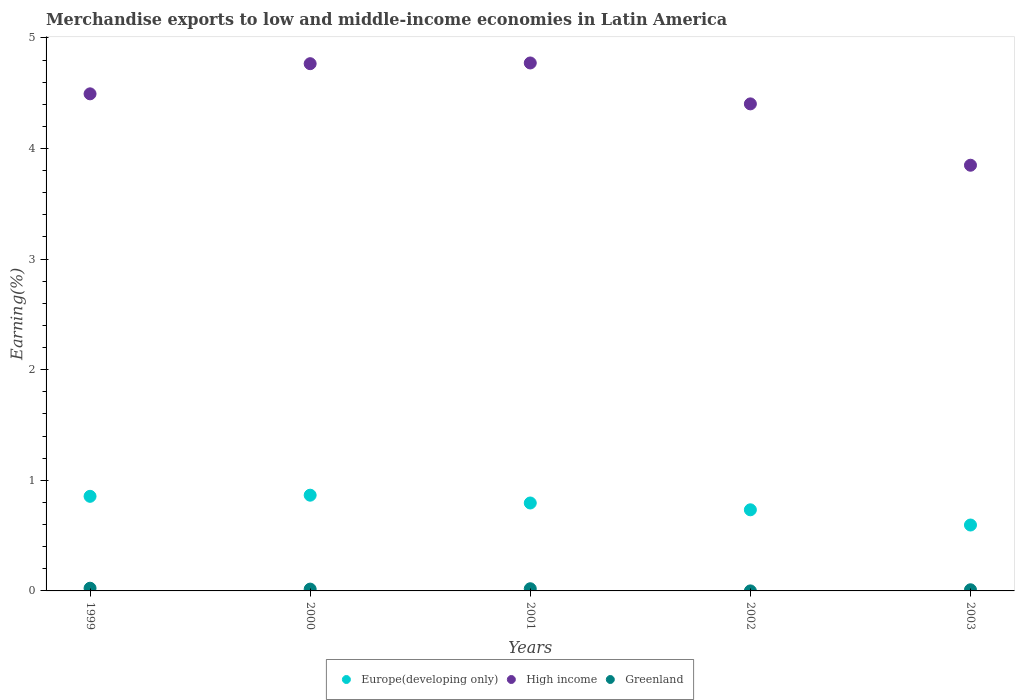How many different coloured dotlines are there?
Your answer should be very brief. 3. Is the number of dotlines equal to the number of legend labels?
Your response must be concise. Yes. What is the percentage of amount earned from merchandise exports in Greenland in 2003?
Provide a short and direct response. 0.01. Across all years, what is the maximum percentage of amount earned from merchandise exports in Greenland?
Make the answer very short. 0.02. Across all years, what is the minimum percentage of amount earned from merchandise exports in High income?
Ensure brevity in your answer.  3.85. In which year was the percentage of amount earned from merchandise exports in High income minimum?
Ensure brevity in your answer.  2003. What is the total percentage of amount earned from merchandise exports in Greenland in the graph?
Give a very brief answer. 0.07. What is the difference between the percentage of amount earned from merchandise exports in High income in 1999 and that in 2001?
Your answer should be very brief. -0.28. What is the difference between the percentage of amount earned from merchandise exports in Europe(developing only) in 2002 and the percentage of amount earned from merchandise exports in Greenland in 2000?
Your answer should be very brief. 0.72. What is the average percentage of amount earned from merchandise exports in High income per year?
Provide a succinct answer. 4.46. In the year 2002, what is the difference between the percentage of amount earned from merchandise exports in Europe(developing only) and percentage of amount earned from merchandise exports in High income?
Offer a terse response. -3.67. In how many years, is the percentage of amount earned from merchandise exports in High income greater than 1.4 %?
Provide a short and direct response. 5. What is the ratio of the percentage of amount earned from merchandise exports in Greenland in 2000 to that in 2003?
Give a very brief answer. 1.59. Is the percentage of amount earned from merchandise exports in Greenland in 1999 less than that in 2003?
Provide a succinct answer. No. Is the difference between the percentage of amount earned from merchandise exports in Europe(developing only) in 2001 and 2003 greater than the difference between the percentage of amount earned from merchandise exports in High income in 2001 and 2003?
Keep it short and to the point. No. What is the difference between the highest and the second highest percentage of amount earned from merchandise exports in Greenland?
Ensure brevity in your answer.  0. What is the difference between the highest and the lowest percentage of amount earned from merchandise exports in High income?
Provide a succinct answer. 0.92. Is the percentage of amount earned from merchandise exports in Europe(developing only) strictly greater than the percentage of amount earned from merchandise exports in High income over the years?
Make the answer very short. No. Is the percentage of amount earned from merchandise exports in High income strictly less than the percentage of amount earned from merchandise exports in Europe(developing only) over the years?
Offer a terse response. No. How many dotlines are there?
Provide a succinct answer. 3. How many years are there in the graph?
Your answer should be compact. 5. What is the difference between two consecutive major ticks on the Y-axis?
Your answer should be compact. 1. Does the graph contain any zero values?
Offer a very short reply. No. Does the graph contain grids?
Give a very brief answer. No. Where does the legend appear in the graph?
Your answer should be very brief. Bottom center. What is the title of the graph?
Provide a succinct answer. Merchandise exports to low and middle-income economies in Latin America. Does "Andorra" appear as one of the legend labels in the graph?
Keep it short and to the point. No. What is the label or title of the X-axis?
Your response must be concise. Years. What is the label or title of the Y-axis?
Give a very brief answer. Earning(%). What is the Earning(%) in Europe(developing only) in 1999?
Provide a succinct answer. 0.86. What is the Earning(%) in High income in 1999?
Provide a short and direct response. 4.49. What is the Earning(%) of Greenland in 1999?
Offer a terse response. 0.02. What is the Earning(%) in Europe(developing only) in 2000?
Your response must be concise. 0.87. What is the Earning(%) of High income in 2000?
Your answer should be very brief. 4.77. What is the Earning(%) in Greenland in 2000?
Your answer should be compact. 0.02. What is the Earning(%) in Europe(developing only) in 2001?
Your response must be concise. 0.79. What is the Earning(%) of High income in 2001?
Keep it short and to the point. 4.77. What is the Earning(%) of Greenland in 2001?
Your answer should be very brief. 0.02. What is the Earning(%) in Europe(developing only) in 2002?
Provide a succinct answer. 0.73. What is the Earning(%) of High income in 2002?
Keep it short and to the point. 4.4. What is the Earning(%) in Greenland in 2002?
Offer a very short reply. 0. What is the Earning(%) in Europe(developing only) in 2003?
Your answer should be compact. 0.6. What is the Earning(%) of High income in 2003?
Provide a short and direct response. 3.85. What is the Earning(%) of Greenland in 2003?
Your answer should be compact. 0.01. Across all years, what is the maximum Earning(%) in Europe(developing only)?
Ensure brevity in your answer.  0.87. Across all years, what is the maximum Earning(%) in High income?
Provide a short and direct response. 4.77. Across all years, what is the maximum Earning(%) in Greenland?
Offer a terse response. 0.02. Across all years, what is the minimum Earning(%) in Europe(developing only)?
Provide a short and direct response. 0.6. Across all years, what is the minimum Earning(%) in High income?
Keep it short and to the point. 3.85. Across all years, what is the minimum Earning(%) in Greenland?
Ensure brevity in your answer.  0. What is the total Earning(%) in Europe(developing only) in the graph?
Keep it short and to the point. 3.85. What is the total Earning(%) of High income in the graph?
Keep it short and to the point. 22.29. What is the total Earning(%) of Greenland in the graph?
Make the answer very short. 0.07. What is the difference between the Earning(%) of Europe(developing only) in 1999 and that in 2000?
Make the answer very short. -0.01. What is the difference between the Earning(%) in High income in 1999 and that in 2000?
Provide a short and direct response. -0.27. What is the difference between the Earning(%) in Greenland in 1999 and that in 2000?
Make the answer very short. 0.01. What is the difference between the Earning(%) of Europe(developing only) in 1999 and that in 2001?
Offer a terse response. 0.06. What is the difference between the Earning(%) of High income in 1999 and that in 2001?
Provide a short and direct response. -0.28. What is the difference between the Earning(%) in Greenland in 1999 and that in 2001?
Your answer should be very brief. 0. What is the difference between the Earning(%) in Europe(developing only) in 1999 and that in 2002?
Keep it short and to the point. 0.12. What is the difference between the Earning(%) in High income in 1999 and that in 2002?
Give a very brief answer. 0.09. What is the difference between the Earning(%) of Greenland in 1999 and that in 2002?
Give a very brief answer. 0.02. What is the difference between the Earning(%) of Europe(developing only) in 1999 and that in 2003?
Your response must be concise. 0.26. What is the difference between the Earning(%) of High income in 1999 and that in 2003?
Provide a succinct answer. 0.65. What is the difference between the Earning(%) in Greenland in 1999 and that in 2003?
Your answer should be very brief. 0.01. What is the difference between the Earning(%) of Europe(developing only) in 2000 and that in 2001?
Offer a very short reply. 0.07. What is the difference between the Earning(%) of High income in 2000 and that in 2001?
Offer a very short reply. -0.01. What is the difference between the Earning(%) in Greenland in 2000 and that in 2001?
Give a very brief answer. -0. What is the difference between the Earning(%) in Europe(developing only) in 2000 and that in 2002?
Make the answer very short. 0.13. What is the difference between the Earning(%) in High income in 2000 and that in 2002?
Keep it short and to the point. 0.36. What is the difference between the Earning(%) of Greenland in 2000 and that in 2002?
Give a very brief answer. 0.02. What is the difference between the Earning(%) of Europe(developing only) in 2000 and that in 2003?
Give a very brief answer. 0.27. What is the difference between the Earning(%) of High income in 2000 and that in 2003?
Offer a very short reply. 0.92. What is the difference between the Earning(%) in Greenland in 2000 and that in 2003?
Provide a succinct answer. 0.01. What is the difference between the Earning(%) of Europe(developing only) in 2001 and that in 2002?
Provide a short and direct response. 0.06. What is the difference between the Earning(%) of High income in 2001 and that in 2002?
Keep it short and to the point. 0.37. What is the difference between the Earning(%) of Greenland in 2001 and that in 2002?
Ensure brevity in your answer.  0.02. What is the difference between the Earning(%) of Europe(developing only) in 2001 and that in 2003?
Make the answer very short. 0.2. What is the difference between the Earning(%) in High income in 2001 and that in 2003?
Your response must be concise. 0.92. What is the difference between the Earning(%) of Greenland in 2001 and that in 2003?
Provide a short and direct response. 0.01. What is the difference between the Earning(%) in Europe(developing only) in 2002 and that in 2003?
Your answer should be very brief. 0.14. What is the difference between the Earning(%) in High income in 2002 and that in 2003?
Offer a very short reply. 0.55. What is the difference between the Earning(%) in Greenland in 2002 and that in 2003?
Offer a very short reply. -0.01. What is the difference between the Earning(%) of Europe(developing only) in 1999 and the Earning(%) of High income in 2000?
Ensure brevity in your answer.  -3.91. What is the difference between the Earning(%) in Europe(developing only) in 1999 and the Earning(%) in Greenland in 2000?
Ensure brevity in your answer.  0.84. What is the difference between the Earning(%) in High income in 1999 and the Earning(%) in Greenland in 2000?
Provide a succinct answer. 4.48. What is the difference between the Earning(%) of Europe(developing only) in 1999 and the Earning(%) of High income in 2001?
Give a very brief answer. -3.92. What is the difference between the Earning(%) in Europe(developing only) in 1999 and the Earning(%) in Greenland in 2001?
Your answer should be very brief. 0.84. What is the difference between the Earning(%) of High income in 1999 and the Earning(%) of Greenland in 2001?
Give a very brief answer. 4.47. What is the difference between the Earning(%) of Europe(developing only) in 1999 and the Earning(%) of High income in 2002?
Keep it short and to the point. -3.55. What is the difference between the Earning(%) of Europe(developing only) in 1999 and the Earning(%) of Greenland in 2002?
Give a very brief answer. 0.86. What is the difference between the Earning(%) in High income in 1999 and the Earning(%) in Greenland in 2002?
Ensure brevity in your answer.  4.49. What is the difference between the Earning(%) in Europe(developing only) in 1999 and the Earning(%) in High income in 2003?
Ensure brevity in your answer.  -2.99. What is the difference between the Earning(%) of Europe(developing only) in 1999 and the Earning(%) of Greenland in 2003?
Your answer should be compact. 0.84. What is the difference between the Earning(%) of High income in 1999 and the Earning(%) of Greenland in 2003?
Your answer should be very brief. 4.48. What is the difference between the Earning(%) of Europe(developing only) in 2000 and the Earning(%) of High income in 2001?
Your answer should be compact. -3.91. What is the difference between the Earning(%) in Europe(developing only) in 2000 and the Earning(%) in Greenland in 2001?
Your answer should be very brief. 0.85. What is the difference between the Earning(%) of High income in 2000 and the Earning(%) of Greenland in 2001?
Ensure brevity in your answer.  4.75. What is the difference between the Earning(%) in Europe(developing only) in 2000 and the Earning(%) in High income in 2002?
Keep it short and to the point. -3.54. What is the difference between the Earning(%) of Europe(developing only) in 2000 and the Earning(%) of Greenland in 2002?
Provide a succinct answer. 0.87. What is the difference between the Earning(%) of High income in 2000 and the Earning(%) of Greenland in 2002?
Offer a very short reply. 4.77. What is the difference between the Earning(%) in Europe(developing only) in 2000 and the Earning(%) in High income in 2003?
Keep it short and to the point. -2.98. What is the difference between the Earning(%) of Europe(developing only) in 2000 and the Earning(%) of Greenland in 2003?
Your response must be concise. 0.86. What is the difference between the Earning(%) in High income in 2000 and the Earning(%) in Greenland in 2003?
Provide a succinct answer. 4.76. What is the difference between the Earning(%) of Europe(developing only) in 2001 and the Earning(%) of High income in 2002?
Provide a short and direct response. -3.61. What is the difference between the Earning(%) in Europe(developing only) in 2001 and the Earning(%) in Greenland in 2002?
Your answer should be very brief. 0.79. What is the difference between the Earning(%) of High income in 2001 and the Earning(%) of Greenland in 2002?
Offer a very short reply. 4.77. What is the difference between the Earning(%) in Europe(developing only) in 2001 and the Earning(%) in High income in 2003?
Your answer should be very brief. -3.05. What is the difference between the Earning(%) of Europe(developing only) in 2001 and the Earning(%) of Greenland in 2003?
Your answer should be compact. 0.78. What is the difference between the Earning(%) in High income in 2001 and the Earning(%) in Greenland in 2003?
Provide a short and direct response. 4.76. What is the difference between the Earning(%) in Europe(developing only) in 2002 and the Earning(%) in High income in 2003?
Ensure brevity in your answer.  -3.12. What is the difference between the Earning(%) of Europe(developing only) in 2002 and the Earning(%) of Greenland in 2003?
Your answer should be very brief. 0.72. What is the difference between the Earning(%) of High income in 2002 and the Earning(%) of Greenland in 2003?
Give a very brief answer. 4.39. What is the average Earning(%) of Europe(developing only) per year?
Provide a succinct answer. 0.77. What is the average Earning(%) of High income per year?
Provide a short and direct response. 4.46. What is the average Earning(%) in Greenland per year?
Keep it short and to the point. 0.01. In the year 1999, what is the difference between the Earning(%) in Europe(developing only) and Earning(%) in High income?
Provide a short and direct response. -3.64. In the year 1999, what is the difference between the Earning(%) in Europe(developing only) and Earning(%) in Greenland?
Your response must be concise. 0.83. In the year 1999, what is the difference between the Earning(%) of High income and Earning(%) of Greenland?
Give a very brief answer. 4.47. In the year 2000, what is the difference between the Earning(%) of Europe(developing only) and Earning(%) of High income?
Your response must be concise. -3.9. In the year 2000, what is the difference between the Earning(%) in Europe(developing only) and Earning(%) in Greenland?
Your answer should be very brief. 0.85. In the year 2000, what is the difference between the Earning(%) of High income and Earning(%) of Greenland?
Your answer should be compact. 4.75. In the year 2001, what is the difference between the Earning(%) in Europe(developing only) and Earning(%) in High income?
Provide a succinct answer. -3.98. In the year 2001, what is the difference between the Earning(%) of Europe(developing only) and Earning(%) of Greenland?
Your answer should be very brief. 0.78. In the year 2001, what is the difference between the Earning(%) of High income and Earning(%) of Greenland?
Give a very brief answer. 4.75. In the year 2002, what is the difference between the Earning(%) of Europe(developing only) and Earning(%) of High income?
Give a very brief answer. -3.67. In the year 2002, what is the difference between the Earning(%) of Europe(developing only) and Earning(%) of Greenland?
Make the answer very short. 0.73. In the year 2002, what is the difference between the Earning(%) of High income and Earning(%) of Greenland?
Offer a very short reply. 4.4. In the year 2003, what is the difference between the Earning(%) of Europe(developing only) and Earning(%) of High income?
Provide a succinct answer. -3.25. In the year 2003, what is the difference between the Earning(%) in Europe(developing only) and Earning(%) in Greenland?
Keep it short and to the point. 0.59. In the year 2003, what is the difference between the Earning(%) in High income and Earning(%) in Greenland?
Your answer should be very brief. 3.84. What is the ratio of the Earning(%) of Europe(developing only) in 1999 to that in 2000?
Make the answer very short. 0.99. What is the ratio of the Earning(%) in High income in 1999 to that in 2000?
Your answer should be very brief. 0.94. What is the ratio of the Earning(%) of Greenland in 1999 to that in 2000?
Offer a terse response. 1.49. What is the ratio of the Earning(%) in Europe(developing only) in 1999 to that in 2001?
Make the answer very short. 1.08. What is the ratio of the Earning(%) of High income in 1999 to that in 2001?
Make the answer very short. 0.94. What is the ratio of the Earning(%) in Greenland in 1999 to that in 2001?
Ensure brevity in your answer.  1.24. What is the ratio of the Earning(%) in Europe(developing only) in 1999 to that in 2002?
Your answer should be compact. 1.17. What is the ratio of the Earning(%) of High income in 1999 to that in 2002?
Offer a very short reply. 1.02. What is the ratio of the Earning(%) of Greenland in 1999 to that in 2002?
Give a very brief answer. 119.63. What is the ratio of the Earning(%) in Europe(developing only) in 1999 to that in 2003?
Provide a succinct answer. 1.44. What is the ratio of the Earning(%) of High income in 1999 to that in 2003?
Ensure brevity in your answer.  1.17. What is the ratio of the Earning(%) in Greenland in 1999 to that in 2003?
Offer a very short reply. 2.36. What is the ratio of the Earning(%) of Europe(developing only) in 2000 to that in 2001?
Ensure brevity in your answer.  1.09. What is the ratio of the Earning(%) of Greenland in 2000 to that in 2001?
Make the answer very short. 0.83. What is the ratio of the Earning(%) of Europe(developing only) in 2000 to that in 2002?
Your response must be concise. 1.18. What is the ratio of the Earning(%) in High income in 2000 to that in 2002?
Ensure brevity in your answer.  1.08. What is the ratio of the Earning(%) in Greenland in 2000 to that in 2002?
Provide a short and direct response. 80.46. What is the ratio of the Earning(%) in Europe(developing only) in 2000 to that in 2003?
Make the answer very short. 1.45. What is the ratio of the Earning(%) in High income in 2000 to that in 2003?
Keep it short and to the point. 1.24. What is the ratio of the Earning(%) of Greenland in 2000 to that in 2003?
Give a very brief answer. 1.59. What is the ratio of the Earning(%) of Europe(developing only) in 2001 to that in 2002?
Keep it short and to the point. 1.08. What is the ratio of the Earning(%) in High income in 2001 to that in 2002?
Provide a short and direct response. 1.08. What is the ratio of the Earning(%) of Greenland in 2001 to that in 2002?
Offer a very short reply. 96.62. What is the ratio of the Earning(%) of Europe(developing only) in 2001 to that in 2003?
Offer a very short reply. 1.33. What is the ratio of the Earning(%) of High income in 2001 to that in 2003?
Your response must be concise. 1.24. What is the ratio of the Earning(%) of Greenland in 2001 to that in 2003?
Make the answer very short. 1.91. What is the ratio of the Earning(%) in Europe(developing only) in 2002 to that in 2003?
Keep it short and to the point. 1.23. What is the ratio of the Earning(%) of High income in 2002 to that in 2003?
Ensure brevity in your answer.  1.14. What is the ratio of the Earning(%) of Greenland in 2002 to that in 2003?
Your response must be concise. 0.02. What is the difference between the highest and the second highest Earning(%) in Europe(developing only)?
Offer a terse response. 0.01. What is the difference between the highest and the second highest Earning(%) in High income?
Your answer should be compact. 0.01. What is the difference between the highest and the second highest Earning(%) of Greenland?
Give a very brief answer. 0. What is the difference between the highest and the lowest Earning(%) of Europe(developing only)?
Provide a succinct answer. 0.27. What is the difference between the highest and the lowest Earning(%) of High income?
Provide a short and direct response. 0.92. What is the difference between the highest and the lowest Earning(%) of Greenland?
Your response must be concise. 0.02. 